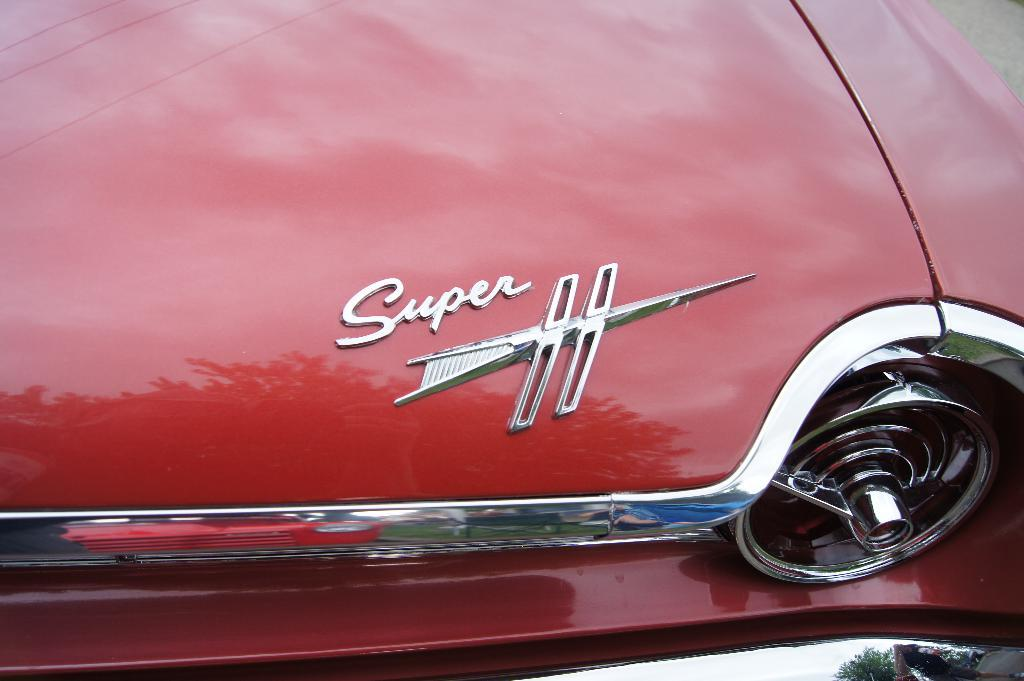What is the main subject of the image? The main subject of the image is a car. What can be seen written on the car? The car has text written on it. What is the color of the car? The car is red in color. What type of vegetation is visible at the bottom right of the image? There are leaves at the bottom right of the image. Can you tell me how many bones are visible in the image? There are no bones present in the image; it features a car with text and leaves. What type of sugar is being used to sweeten the car in the image? There is no sugar present in the image, as it features a car with text and leaves. 